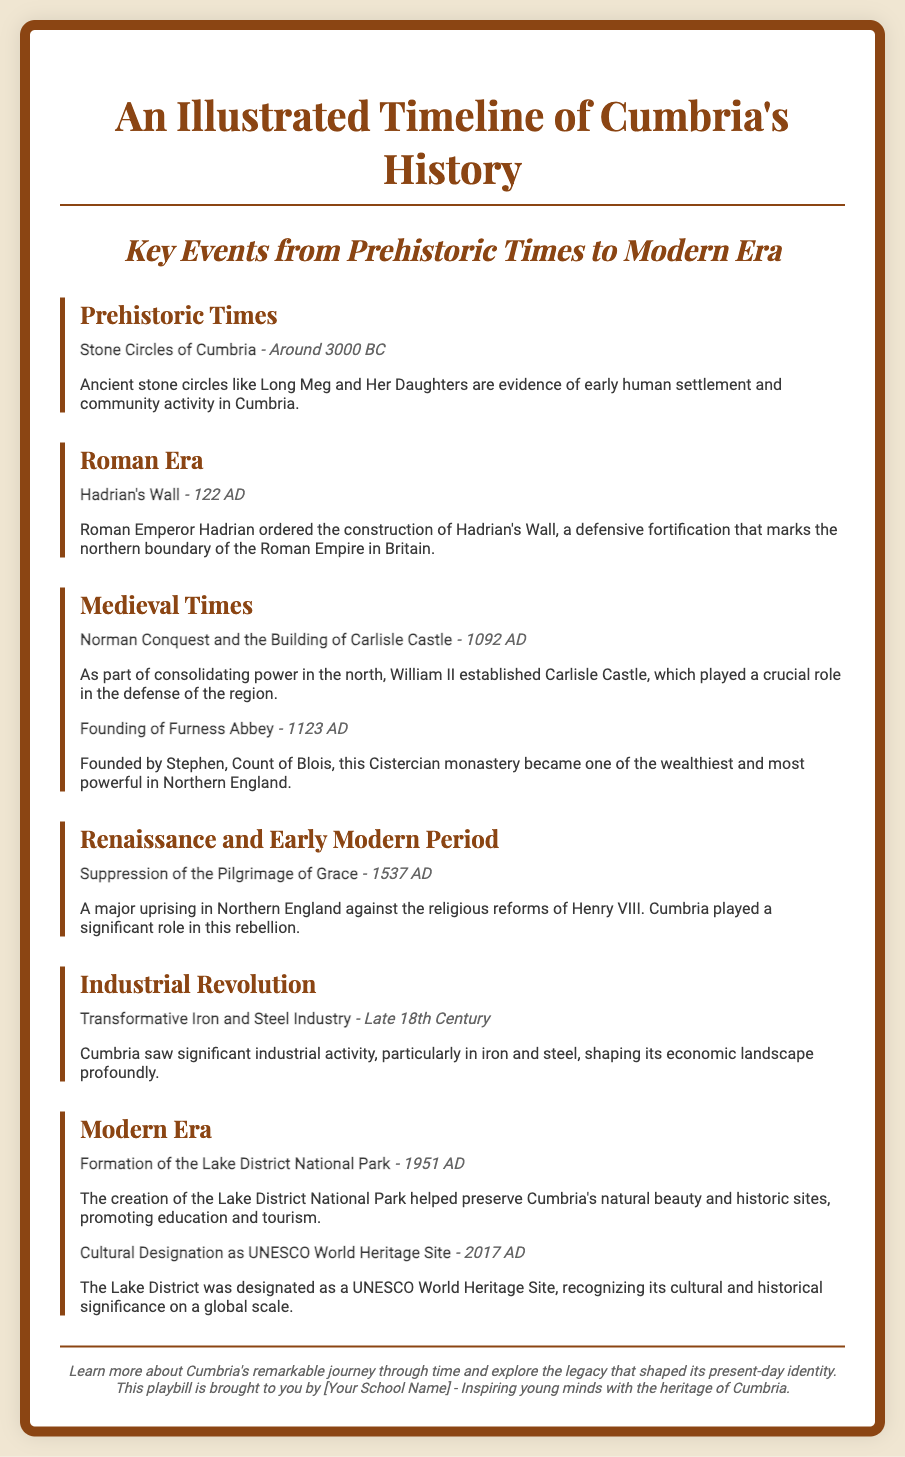what significant structure was built in 122 AD? The document mentions Hadrian's Wall, which was constructed under the order of Emperor Hadrian.
Answer: Hadrian's Wall when was Furness Abbey founded? The founding of Furness Abbey is stated to be in the year 1123 AD in the timeline.
Answer: 1123 AD what event occurred around 3000 BC? The document describes the Stone Circles of Cumbria as an event from prehistoric times around this date.
Answer: Stone Circles of Cumbria which cultural designation was received in 2017? The document notes that the Lake District was designated as a UNESCO World Heritage Site in 2017.
Answer: UNESCO World Heritage Site what industry transformed Cumbria in the late 18th century? The timeline indicates that the iron and steel industry saw significant development during this period.
Answer: Iron and steel industry what was a major event against Henry VIII's reforms? The document refers to the Suppression of the Pilgrimage of Grace as a major uprising associated with Henry VIII's religious reforms.
Answer: Suppression of the Pilgrimage of Grace when was the Lake District National Park formed? The formation of the Lake District National Park is mentioned to have taken place in 1951 AD.
Answer: 1951 AD which king was associated with the construction of Carlisle Castle? The timeline states that William II was responsible for establishing Carlisle Castle in 1092 AD.
Answer: William II what type of document is this? The document is a playbill focused on an illustrated timeline of Cumbria's history.
Answer: Playbill 